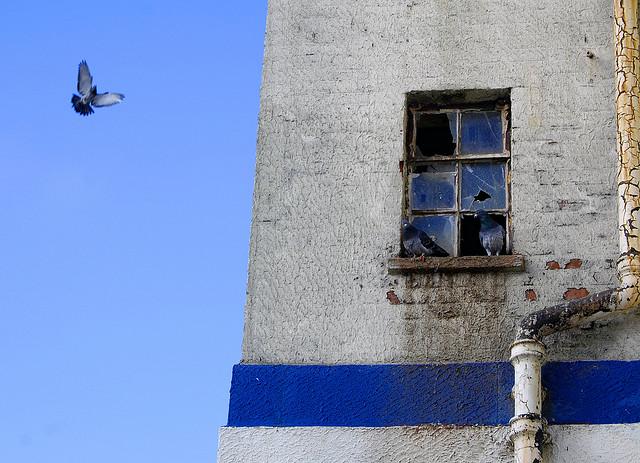How many squares are in the window?
Be succinct. 6. Is there a bird flying?
Concise answer only. Yes. What color is the sky?
Be succinct. Blue. 